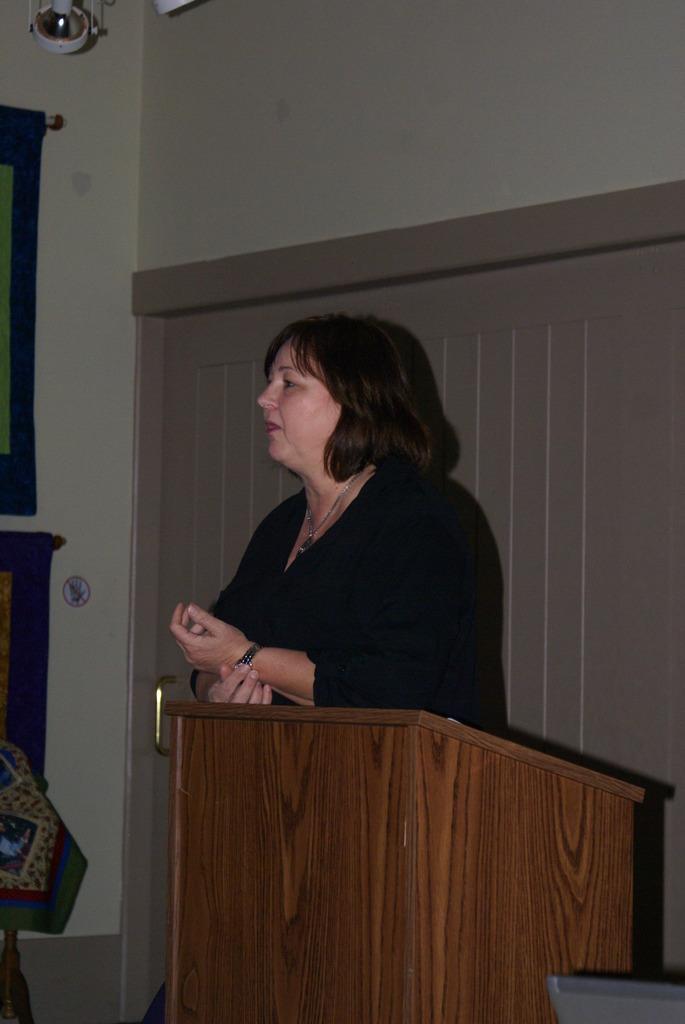How would you summarize this image in a sentence or two? In this image, we can see a brown color podium, there is a woman standing, in the background, we can see a door and there is a wall. 